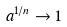Convert formula to latex. <formula><loc_0><loc_0><loc_500><loc_500>a ^ { 1 / n } \rightarrow 1</formula> 